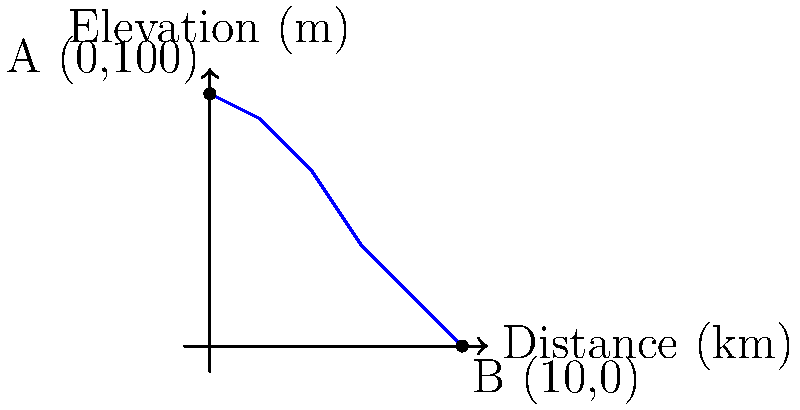Given the topographic profile of a watershed shown in the graph, estimate the time of concentration using the Kirpich formula. The watershed has a length of 10 km and a total elevation difference of 100 m. Assume the watershed has a moderately developed drainage system. How would you approach this problem algorithmically? To solve this problem algorithmically, we can break it down into the following steps:

1. Identify the given information:
   - Watershed length (L) = 10 km
   - Elevation difference (H) = 100 m

2. Convert units if necessary:
   - L = 10 km = 10,000 m

3. Recall the Kirpich formula for time of concentration (tc):
   $$ t_c = 0.0195 \cdot L^{0.77} \cdot S^{-0.385} $$
   where:
   - tc is in minutes
   - L is the length of the watershed in meters
   - S is the average slope of the watershed (m/m)

4. Calculate the average slope (S):
   $$ S = \frac{H}{L} = \frac{100 \text{ m}}{10,000 \text{ m}} = 0.01 \text{ m/m} $$

5. Plug the values into the Kirpich formula:
   $$ t_c = 0.0195 \cdot (10,000)^{0.77} \cdot (0.01)^{-0.385} $$

6. Evaluate the expression:
   $$ t_c \approx 51.7 \text{ minutes} $$

7. Round the result to a reasonable number of significant figures:
   $$ t_c \approx 52 \text{ minutes} $$

This algorithmic approach demonstrates how to break down a complex problem into manageable steps, which is crucial in computer science and programming. It also shows how to handle unit conversions, apply mathematical formulas, and perform calculations systematically.
Answer: 52 minutes 